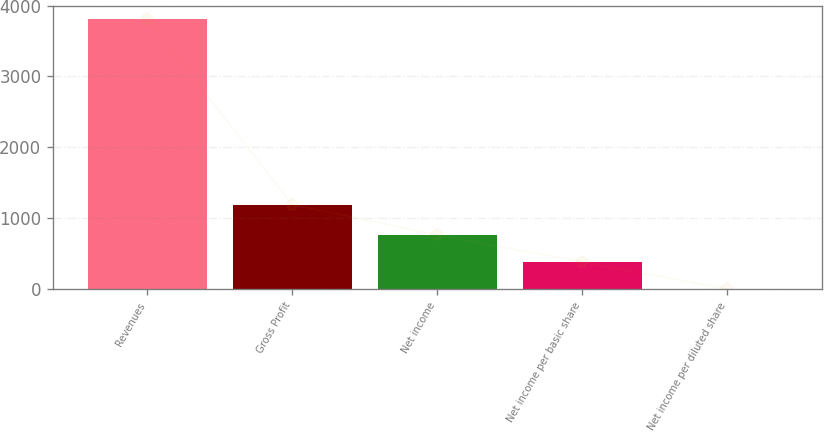<chart> <loc_0><loc_0><loc_500><loc_500><bar_chart><fcel>Revenues<fcel>Gross Profit<fcel>Net income<fcel>Net income per basic share<fcel>Net income per diluted share<nl><fcel>3810.2<fcel>1193.4<fcel>763.16<fcel>382.28<fcel>1.4<nl></chart> 